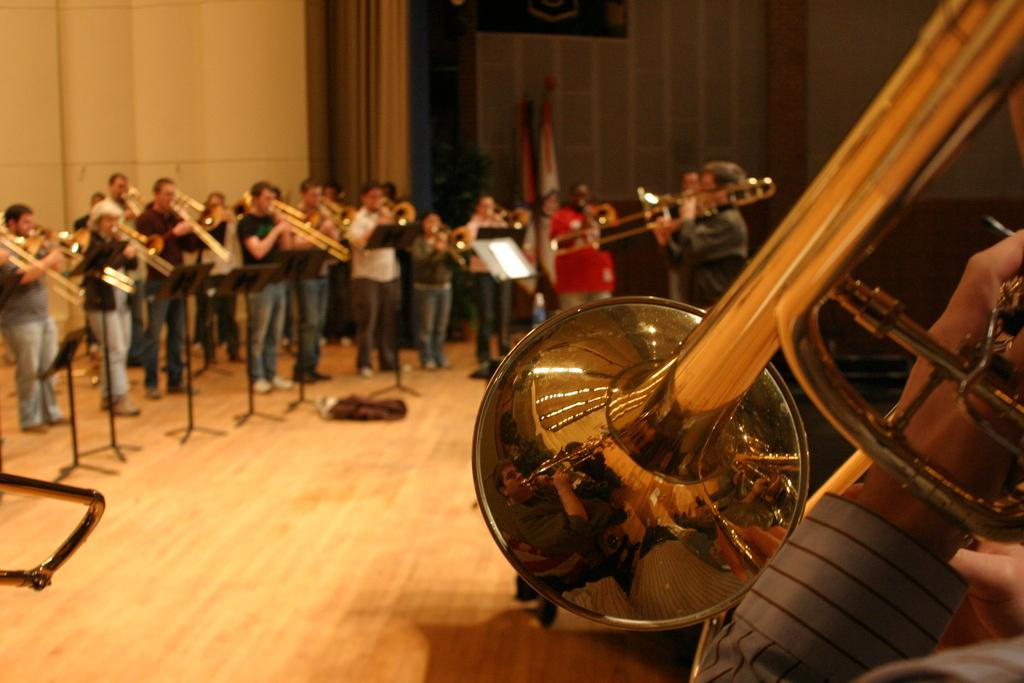What are the people in the image doing? The people in the image are playing musical instruments. What can be seen in the image besides the people playing instruments? There are stands, papers, a wall, and curtains in the image. What type of liquid can be seen dripping from the eggnog in the image? There is no eggnog present in the image, so it is not possible to determine if any liquid is dripping from it. 